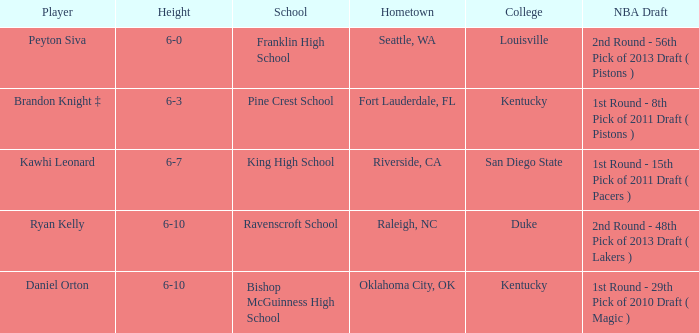Which height is associated with Franklin High School? 6-0. Parse the table in full. {'header': ['Player', 'Height', 'School', 'Hometown', 'College', 'NBA Draft'], 'rows': [['Peyton Siva', '6-0', 'Franklin High School', 'Seattle, WA', 'Louisville', '2nd Round - 56th Pick of 2013 Draft ( Pistons )'], ['Brandon Knight ‡', '6-3', 'Pine Crest School', 'Fort Lauderdale, FL', 'Kentucky', '1st Round - 8th Pick of 2011 Draft ( Pistons )'], ['Kawhi Leonard', '6-7', 'King High School', 'Riverside, CA', 'San Diego State', '1st Round - 15th Pick of 2011 Draft ( Pacers )'], ['Ryan Kelly', '6-10', 'Ravenscroft School', 'Raleigh, NC', 'Duke', '2nd Round - 48th Pick of 2013 Draft ( Lakers )'], ['Daniel Orton', '6-10', 'Bishop McGuinness High School', 'Oklahoma City, OK', 'Kentucky', '1st Round - 29th Pick of 2010 Draft ( Magic )']]} 